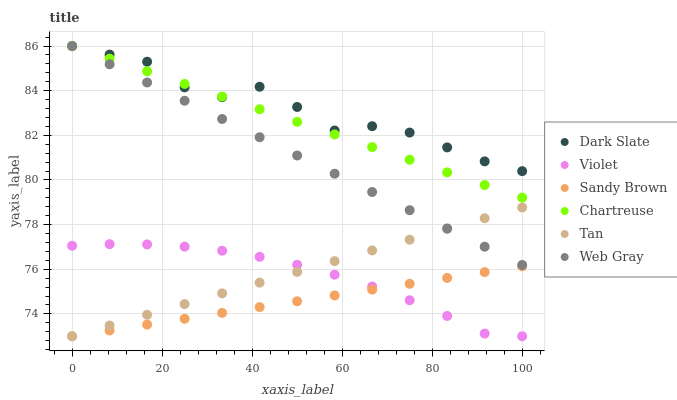Does Sandy Brown have the minimum area under the curve?
Answer yes or no. Yes. Does Dark Slate have the maximum area under the curve?
Answer yes or no. Yes. Does Chartreuse have the minimum area under the curve?
Answer yes or no. No. Does Chartreuse have the maximum area under the curve?
Answer yes or no. No. Is Chartreuse the smoothest?
Answer yes or no. Yes. Is Dark Slate the roughest?
Answer yes or no. Yes. Is Dark Slate the smoothest?
Answer yes or no. No. Is Chartreuse the roughest?
Answer yes or no. No. Does Violet have the lowest value?
Answer yes or no. Yes. Does Chartreuse have the lowest value?
Answer yes or no. No. Does Chartreuse have the highest value?
Answer yes or no. Yes. Does Violet have the highest value?
Answer yes or no. No. Is Tan less than Dark Slate?
Answer yes or no. Yes. Is Chartreuse greater than Violet?
Answer yes or no. Yes. Does Violet intersect Sandy Brown?
Answer yes or no. Yes. Is Violet less than Sandy Brown?
Answer yes or no. No. Is Violet greater than Sandy Brown?
Answer yes or no. No. Does Tan intersect Dark Slate?
Answer yes or no. No. 